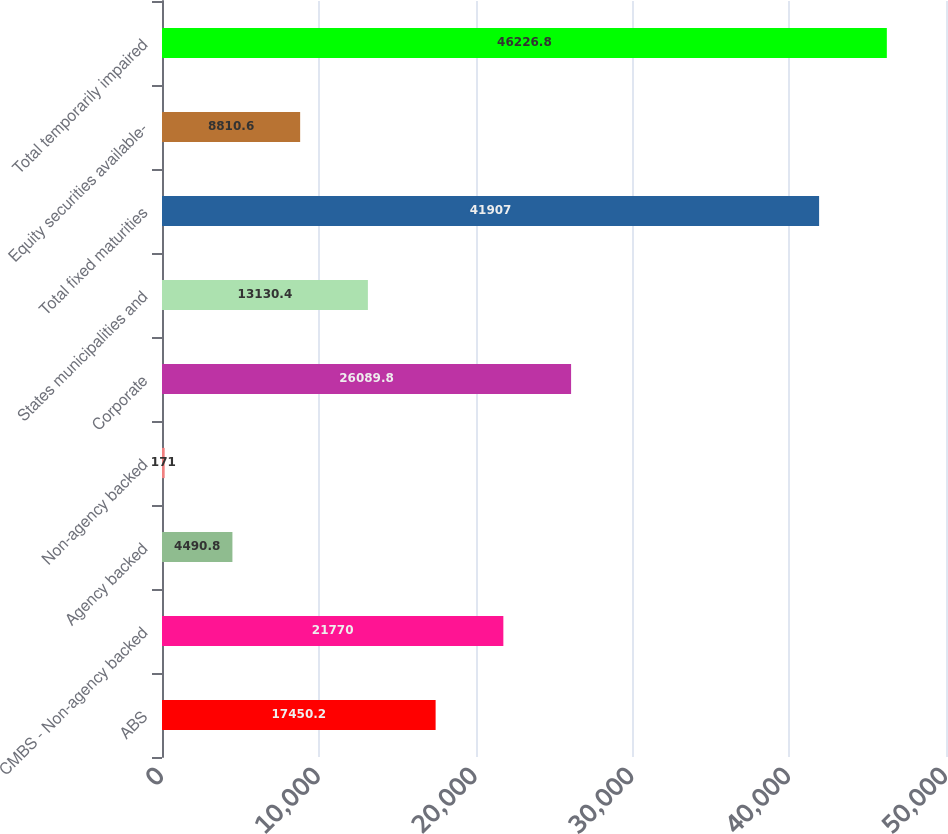Convert chart to OTSL. <chart><loc_0><loc_0><loc_500><loc_500><bar_chart><fcel>ABS<fcel>CMBS - Non-agency backed<fcel>Agency backed<fcel>Non-agency backed<fcel>Corporate<fcel>States municipalities and<fcel>Total fixed maturities<fcel>Equity securities available-<fcel>Total temporarily impaired<nl><fcel>17450.2<fcel>21770<fcel>4490.8<fcel>171<fcel>26089.8<fcel>13130.4<fcel>41907<fcel>8810.6<fcel>46226.8<nl></chart> 